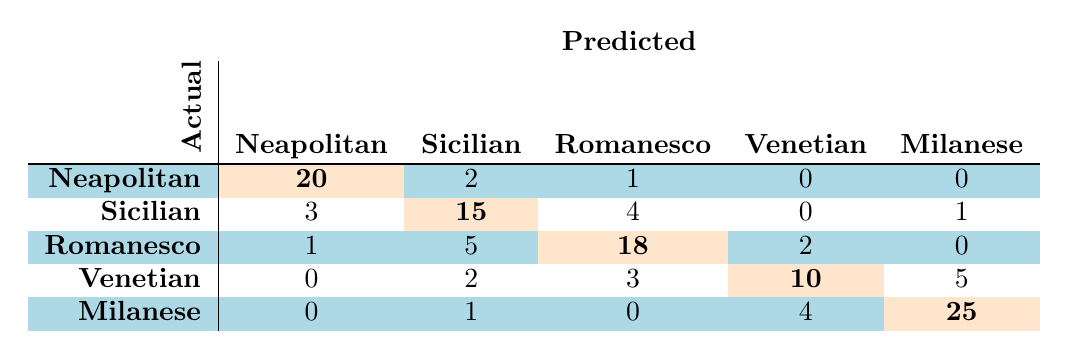What is the number of times Neapolitan was correctly identified? The value for Neapolitan, which indicates the number of times it was correctly identified, is found on the diagonal of the confusion matrix. In the row for Neapolitan and the column for Neapolitan, the value is 20.
Answer: 20 How many times was Sicilian misclassified as Romanesco? To find how many times Sicilian was misclassified as Romanesco, we look at the row for Sicilian and the column for Romanesco in the confusion matrix. The value in that cell is 4.
Answer: 4 What is the total number of predictions made for the Venetian dialect? To calculate the total predictions for Venetian, we must sum all values in the row for Venetian: 0 + 2 + 3 + 10 + 5 = 20.
Answer: 20 Is it true that Milanese was incorrectly labeled more frequently than Neapolitan? To answer this, we need to check the off-diagonal counts for Milanese and Neapolitan. The total for Milanese (1 + 0 + 4) is 5, while for Neapolitan (2 + 1) is 3. Since 5 > 3, the statement is true.
Answer: Yes How many errors were made in recognizing Romanesco? The errors in recognizing Romanesco are found by summing all the off-diagonal values in the Romanesco row: 1 + 5 + 2 + 0 = 8.
Answer: 8 What is the total number of correct identifications across all dialects? To obtain the total number of correct identifications, we need to sum all diagonal values of the confusion matrix: 20 (Neapolitan) + 15 (Sicilian) + 18 (Romanesco) + 10 (Venetian) + 25 (Milanese) = 98.
Answer: 98 What is the misclassification rate for the Sicilian dialect? To determine the misclassification rate for Sicilian, we first find the total predictions for Sicilian (3 + 15 + 4 + 0 + 1 = 23). The number of misclassifications is the sum of all off-diagonal values in the Sicilian row (3 + 4 + 0 + 1 = 8). The misclassification rate is then (8 / 23) * 100, approximately 34.78%.
Answer: Approximately 34.78% Which dialect has the highest number of correct predictions? The correct predictions for each dialect are on the diagonal: Neapolitan (20), Sicilian (15), Romanesco (18), Venetian (10), Milanese (25). The highest value is 25, corresponding to Milanese.
Answer: Milanese What is the average number of misclassifications across all dialects? To calculate the average number of misclassifications, we must sum the off-diagonal values for each dialect: 2 (Neapolitan) + (3 + 4 + 0 + 1) (Sicilian) + (1 + 5 + 2 + 0) (Romanesco) + (0 + 2 + 3 + 5) (Venetian) + (1 + 0 + 4) (Milanese) = 2 + 8 + 8 + 10 + 5 = 33. The number of dialects (5) makes the average 33/5 = 6.6.
Answer: 6.6 